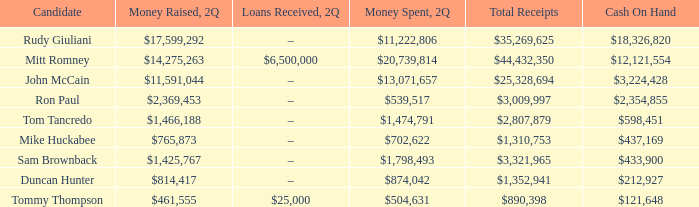Would you be able to parse every entry in this table? {'header': ['Candidate', 'Money Raised, 2Q', 'Loans Received, 2Q', 'Money Spent, 2Q', 'Total Receipts', 'Cash On Hand'], 'rows': [['Rudy Giuliani', '$17,599,292', '–', '$11,222,806', '$35,269,625', '$18,326,820'], ['Mitt Romney', '$14,275,263', '$6,500,000', '$20,739,814', '$44,432,350', '$12,121,554'], ['John McCain', '$11,591,044', '–', '$13,071,657', '$25,328,694', '$3,224,428'], ['Ron Paul', '$2,369,453', '–', '$539,517', '$3,009,997', '$2,354,855'], ['Tom Tancredo', '$1,466,188', '–', '$1,474,791', '$2,807,879', '$598,451'], ['Mike Huckabee', '$765,873', '–', '$702,622', '$1,310,753', '$437,169'], ['Sam Brownback', '$1,425,767', '–', '$1,798,493', '$3,321,965', '$433,900'], ['Duncan Hunter', '$814,417', '–', '$874,042', '$1,352,941', '$212,927'], ['Tommy Thompson', '$461,555', '$25,000', '$504,631', '$890,398', '$121,648']]} How much money was generated when 2q received a total of $890,398 in income? $461,555. 